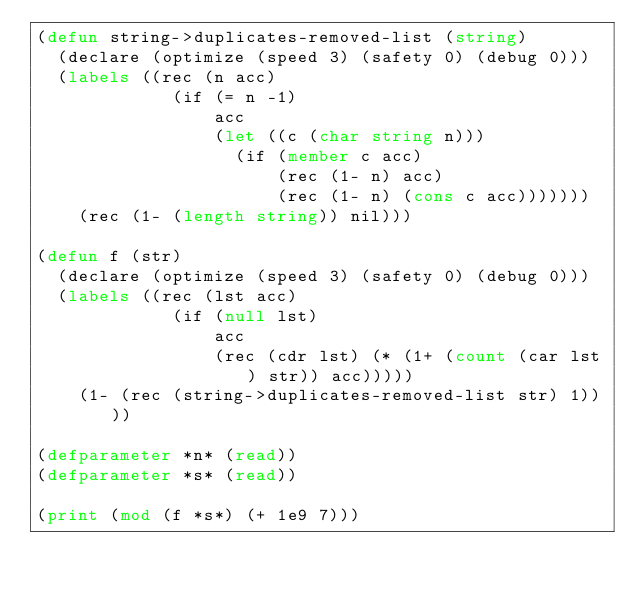<code> <loc_0><loc_0><loc_500><loc_500><_Lisp_>(defun string->duplicates-removed-list (string)
  (declare (optimize (speed 3) (safety 0) (debug 0)))
  (labels ((rec (n acc)
             (if (= n -1)
                 acc
                 (let ((c (char string n)))
                   (if (member c acc)
                       (rec (1- n) acc)
                       (rec (1- n) (cons c acc)))))))
    (rec (1- (length string)) nil)))

(defun f (str)
  (declare (optimize (speed 3) (safety 0) (debug 0)))
  (labels ((rec (lst acc)
             (if (null lst)
                 acc
                 (rec (cdr lst) (* (1+ (count (car lst) str)) acc)))))
    (1- (rec (string->duplicates-removed-list str) 1))))

(defparameter *n* (read))
(defparameter *s* (read))

(print (mod (f *s*) (+ 1e9 7)))
</code> 